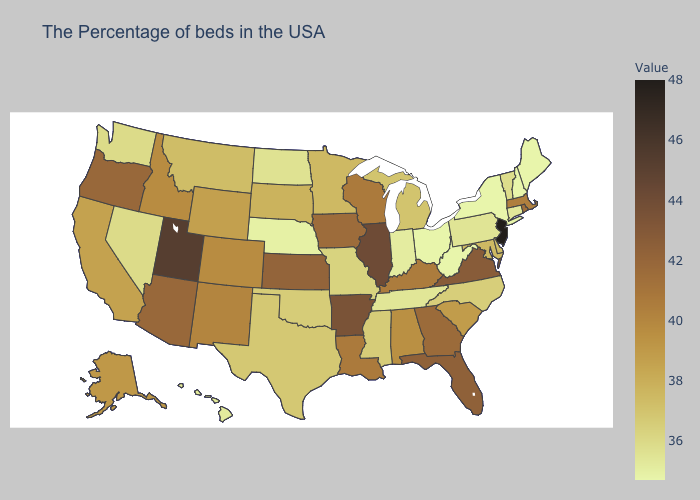Does Texas have a lower value than Alabama?
Concise answer only. Yes. Which states have the lowest value in the USA?
Give a very brief answer. Maine, New Hampshire, New York, West Virginia, Ohio. Which states have the lowest value in the USA?
Short answer required. Maine, New Hampshire, New York, West Virginia, Ohio. Does New Jersey have the highest value in the USA?
Keep it brief. Yes. Which states have the lowest value in the Northeast?
Be succinct. Maine, New Hampshire, New York. Does Alaska have the lowest value in the USA?
Write a very short answer. No. Which states hav the highest value in the South?
Concise answer only. Arkansas. 